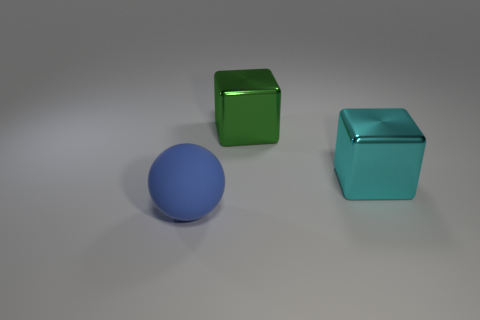Add 2 large cyan things. How many objects exist? 5 Subtract all balls. How many objects are left? 2 Add 1 blue spheres. How many blue spheres exist? 2 Subtract 0 yellow spheres. How many objects are left? 3 Subtract all big rubber cylinders. Subtract all metallic things. How many objects are left? 1 Add 1 large blue rubber spheres. How many large blue rubber spheres are left? 2 